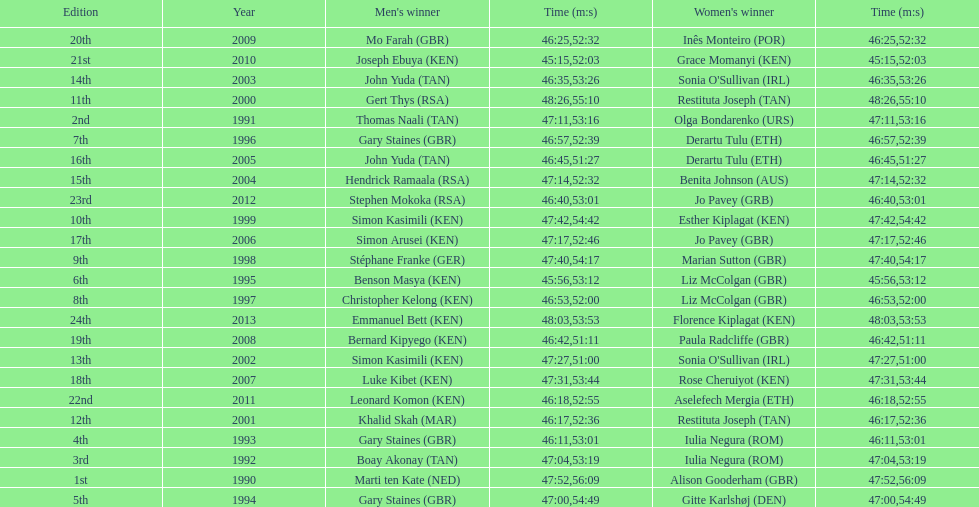What is the name of the first women's winner? Alison Gooderham. 